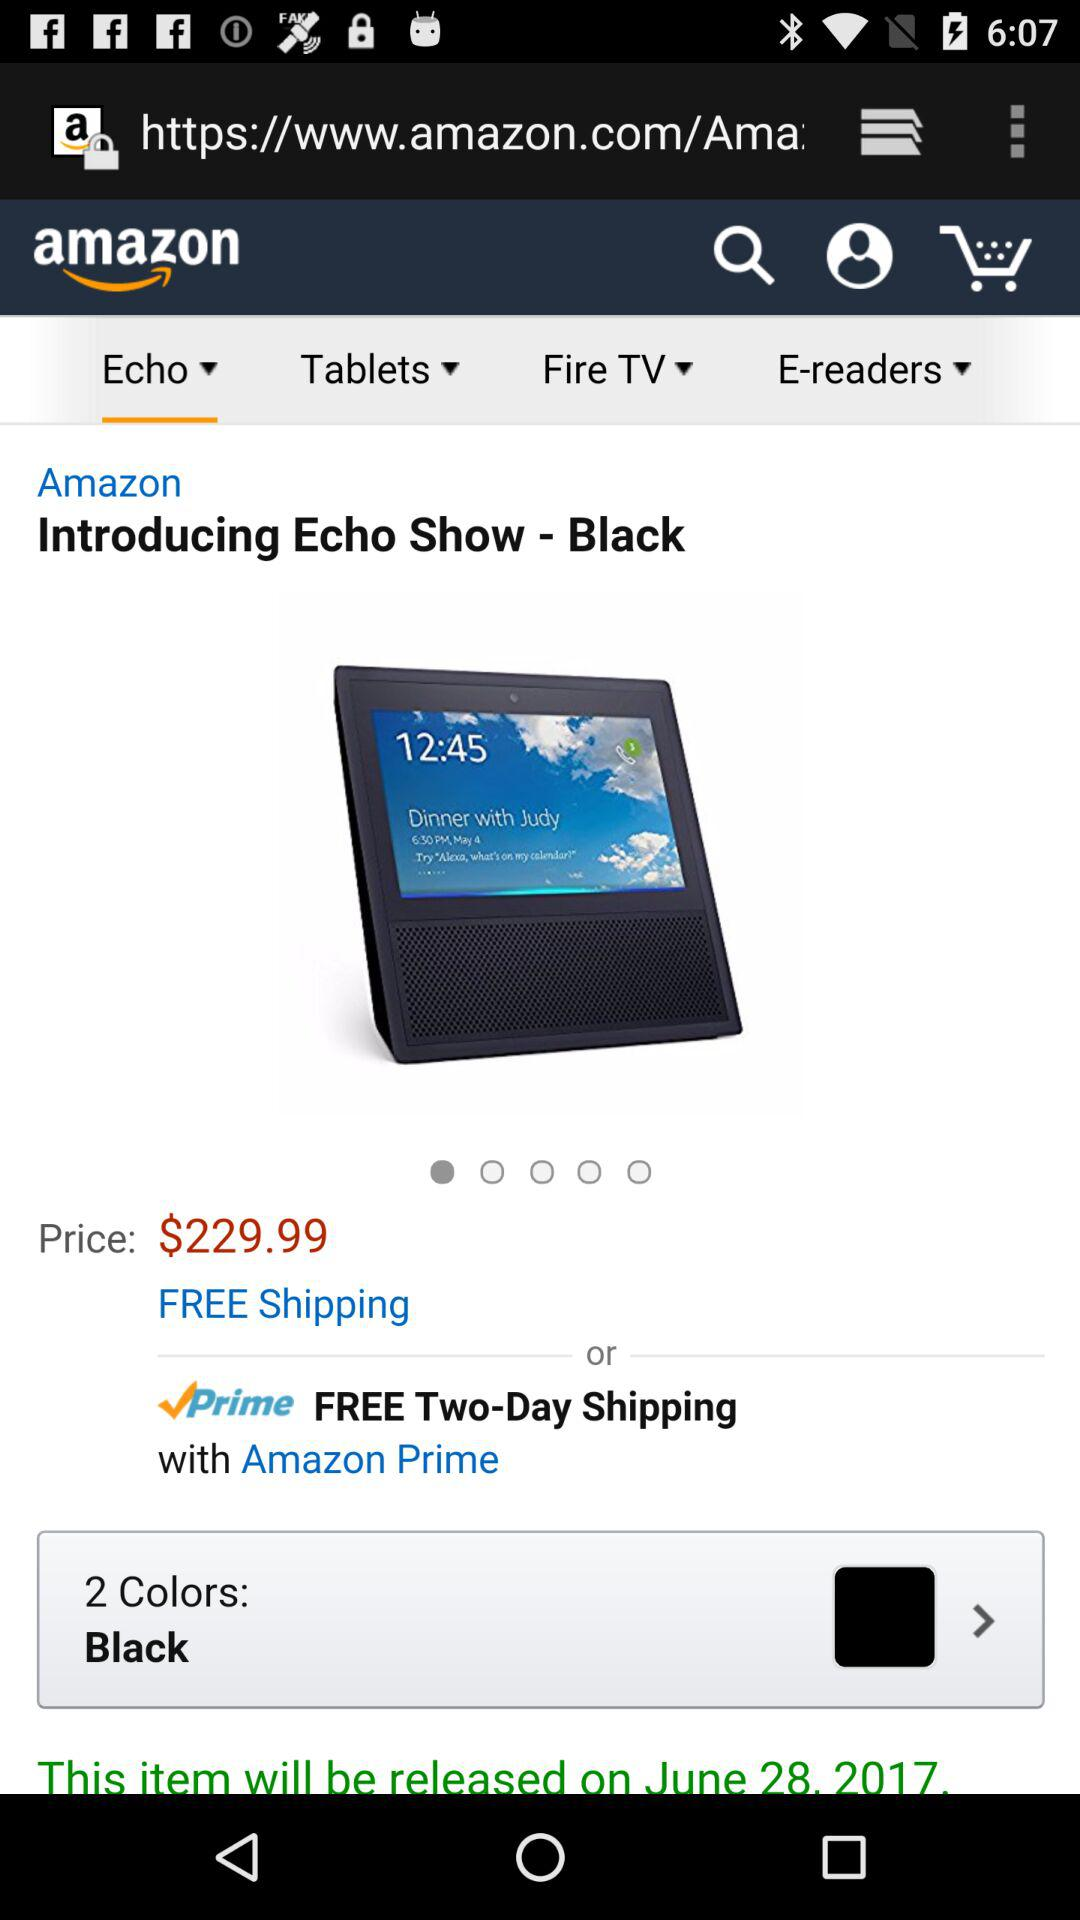How many colors are available for the Echo Show?
Answer the question using a single word or phrase. 2 